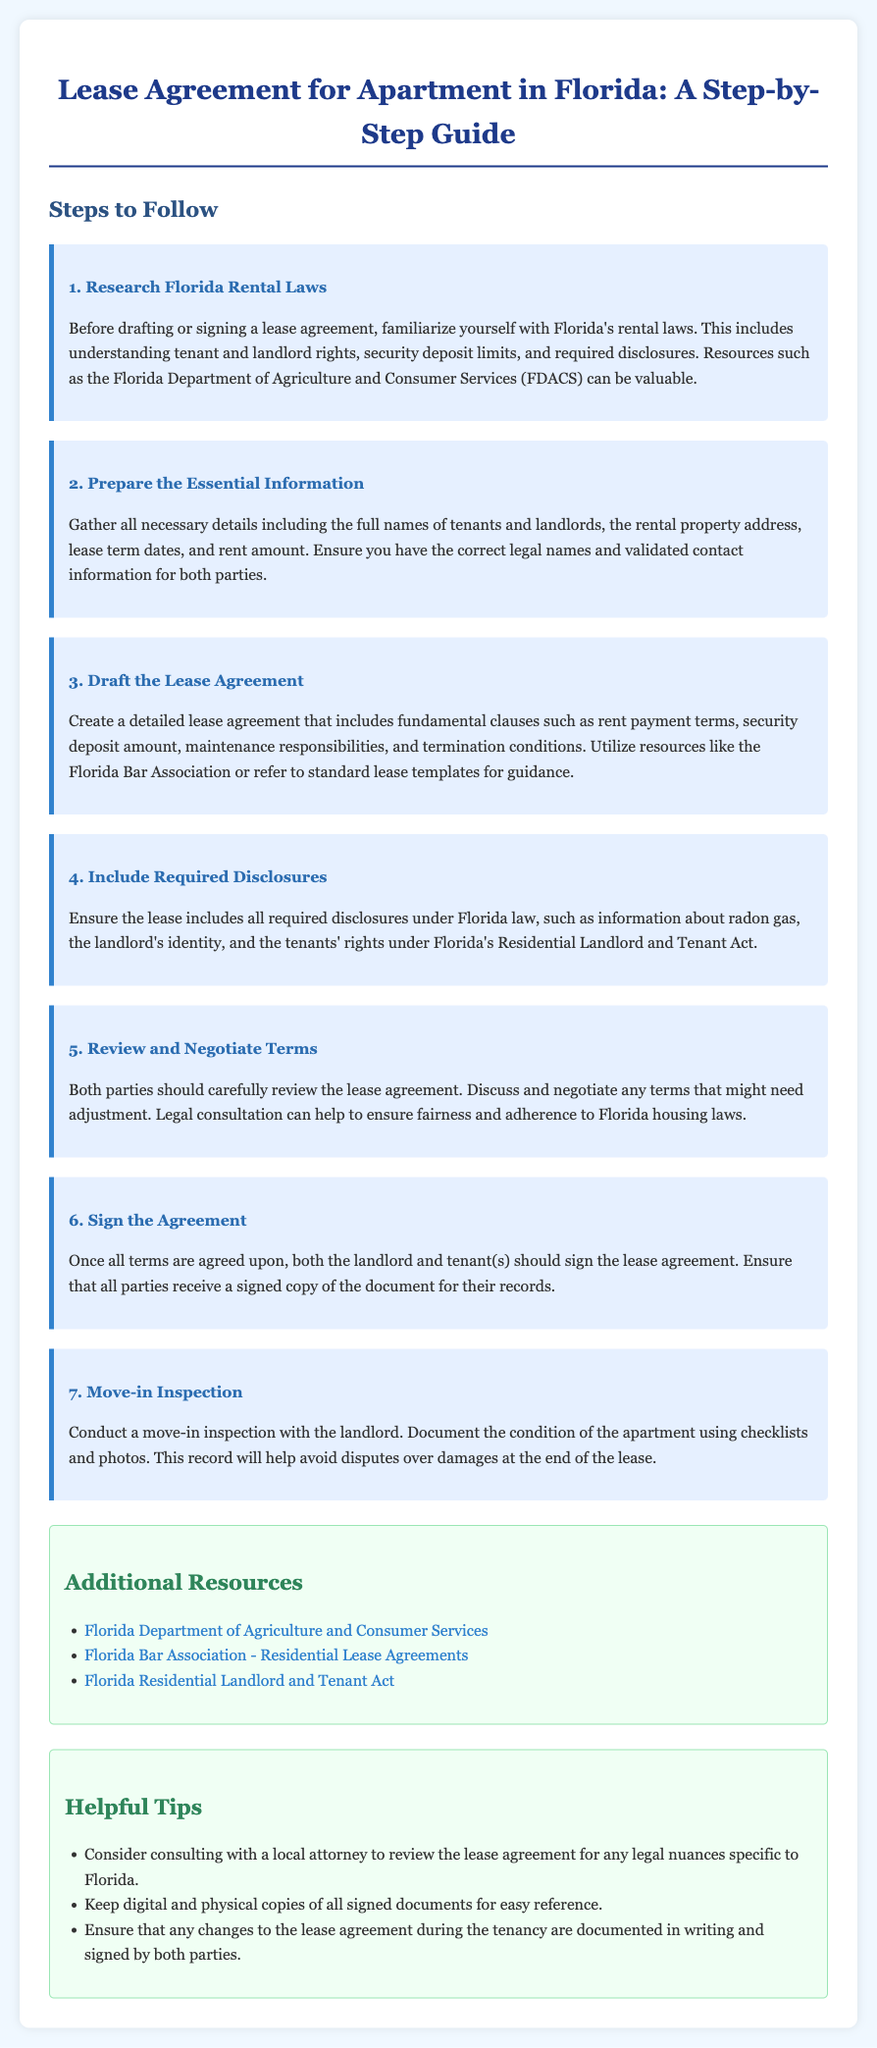what is the first step to follow in the lease agreement process? The first step mentioned is to research Florida rental laws which includes understanding tenant and landlord rights, security deposit limits, and required disclosures.
Answer: Research Florida Rental Laws what should be included in the lease agreement according to the guide? The lease agreement should include fundamental clauses such as rent payment terms, security deposit amount, maintenance responsibilities, and termination conditions.
Answer: Fundamental clauses what are the required disclosures to include in the lease? Required disclosures under Florida law include information about radon gas, the landlord's identity, and the tenants' rights under Florida's Residential Landlord and Tenant Act.
Answer: Required disclosures how many steps are listed in the guide? The guide lists a total of seven steps to follow for the lease agreement process.
Answer: Seven steps which organization is suggested as a resource for understanding lease agreements? The Florida Bar Association is suggested as a valuable resource for guidance in drafting lease agreements.
Answer: Florida Bar Association what is the purpose of conducting a move-in inspection? The move-in inspection aims to document the condition of the apartment using checklists and photos to help avoid disputes over damages at the end of the lease.
Answer: Avoid disputes over damages what is one helpful tip provided in the document? One helpful tip is to keep digital and physical copies of all signed documents for easy reference.
Answer: Keep signed documents copies what legal consultation is advised in the document? The document advises consulting with a local attorney to review the lease agreement for any legal nuances specific to Florida.
Answer: Consult with a local attorney 